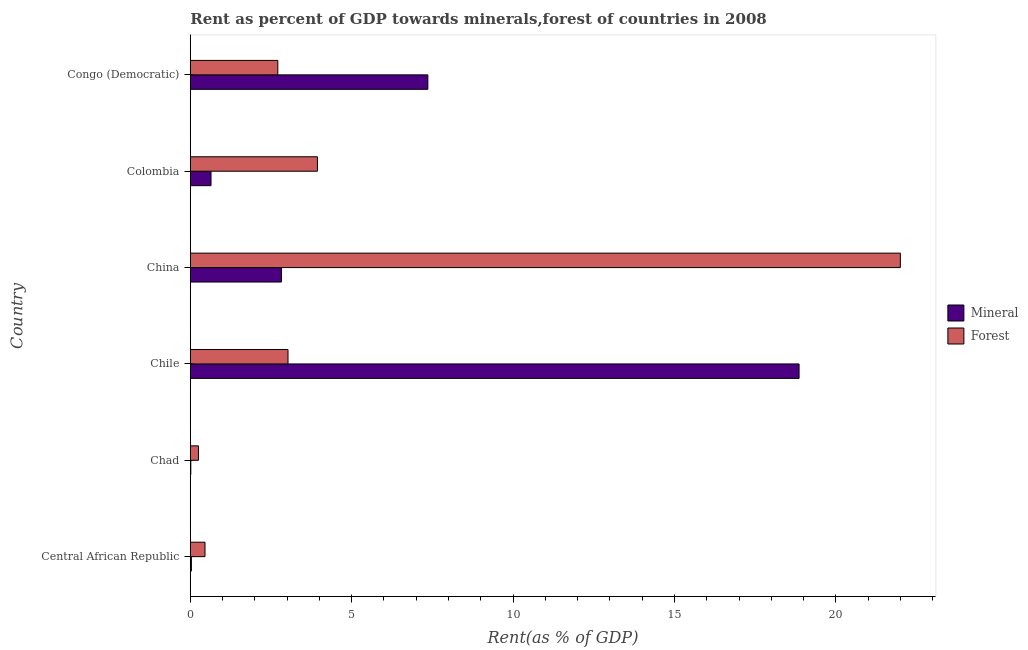How many groups of bars are there?
Provide a short and direct response. 6. How many bars are there on the 3rd tick from the top?
Your answer should be very brief. 2. What is the label of the 2nd group of bars from the top?
Your answer should be very brief. Colombia. In how many cases, is the number of bars for a given country not equal to the number of legend labels?
Offer a terse response. 0. What is the mineral rent in Congo (Democratic)?
Provide a short and direct response. 7.36. Across all countries, what is the maximum forest rent?
Your response must be concise. 22. Across all countries, what is the minimum forest rent?
Offer a terse response. 0.25. In which country was the forest rent maximum?
Make the answer very short. China. In which country was the mineral rent minimum?
Provide a succinct answer. Chad. What is the total mineral rent in the graph?
Provide a short and direct response. 29.73. What is the difference between the mineral rent in Central African Republic and that in Congo (Democratic)?
Offer a terse response. -7.33. What is the difference between the mineral rent in Colombia and the forest rent in Chile?
Provide a succinct answer. -2.39. What is the average forest rent per country?
Keep it short and to the point. 5.4. What is the difference between the forest rent and mineral rent in China?
Keep it short and to the point. 19.18. In how many countries, is the forest rent greater than 5 %?
Ensure brevity in your answer.  1. What is the ratio of the forest rent in Chad to that in Congo (Democratic)?
Make the answer very short. 0.09. Is the difference between the mineral rent in China and Congo (Democratic) greater than the difference between the forest rent in China and Congo (Democratic)?
Offer a terse response. No. What is the difference between the highest and the second highest forest rent?
Provide a succinct answer. 18.06. What is the difference between the highest and the lowest forest rent?
Offer a very short reply. 21.75. What does the 2nd bar from the top in Chile represents?
Your answer should be very brief. Mineral. What does the 2nd bar from the bottom in Chile represents?
Keep it short and to the point. Forest. How many bars are there?
Make the answer very short. 12. What is the difference between two consecutive major ticks on the X-axis?
Make the answer very short. 5. Does the graph contain grids?
Keep it short and to the point. No. How many legend labels are there?
Provide a succinct answer. 2. What is the title of the graph?
Provide a succinct answer. Rent as percent of GDP towards minerals,forest of countries in 2008. What is the label or title of the X-axis?
Your answer should be very brief. Rent(as % of GDP). What is the Rent(as % of GDP) of Mineral in Central African Republic?
Offer a very short reply. 0.03. What is the Rent(as % of GDP) of Forest in Central African Republic?
Ensure brevity in your answer.  0.46. What is the Rent(as % of GDP) in Mineral in Chad?
Offer a terse response. 0.02. What is the Rent(as % of GDP) of Forest in Chad?
Provide a short and direct response. 0.25. What is the Rent(as % of GDP) in Mineral in Chile?
Your answer should be compact. 18.86. What is the Rent(as % of GDP) in Forest in Chile?
Offer a terse response. 3.03. What is the Rent(as % of GDP) in Mineral in China?
Provide a short and direct response. 2.82. What is the Rent(as % of GDP) of Forest in China?
Your answer should be compact. 22. What is the Rent(as % of GDP) of Mineral in Colombia?
Offer a very short reply. 0.64. What is the Rent(as % of GDP) in Forest in Colombia?
Give a very brief answer. 3.94. What is the Rent(as % of GDP) of Mineral in Congo (Democratic)?
Keep it short and to the point. 7.36. What is the Rent(as % of GDP) of Forest in Congo (Democratic)?
Provide a succinct answer. 2.71. Across all countries, what is the maximum Rent(as % of GDP) of Mineral?
Offer a terse response. 18.86. Across all countries, what is the maximum Rent(as % of GDP) in Forest?
Your response must be concise. 22. Across all countries, what is the minimum Rent(as % of GDP) in Mineral?
Ensure brevity in your answer.  0.02. Across all countries, what is the minimum Rent(as % of GDP) in Forest?
Offer a terse response. 0.25. What is the total Rent(as % of GDP) in Mineral in the graph?
Ensure brevity in your answer.  29.73. What is the total Rent(as % of GDP) of Forest in the graph?
Your answer should be compact. 32.38. What is the difference between the Rent(as % of GDP) in Mineral in Central African Republic and that in Chad?
Provide a succinct answer. 0.02. What is the difference between the Rent(as % of GDP) of Forest in Central African Republic and that in Chad?
Keep it short and to the point. 0.2. What is the difference between the Rent(as % of GDP) in Mineral in Central African Republic and that in Chile?
Offer a terse response. -18.83. What is the difference between the Rent(as % of GDP) in Forest in Central African Republic and that in Chile?
Your answer should be very brief. -2.57. What is the difference between the Rent(as % of GDP) of Mineral in Central African Republic and that in China?
Offer a very short reply. -2.79. What is the difference between the Rent(as % of GDP) of Forest in Central African Republic and that in China?
Your answer should be compact. -21.54. What is the difference between the Rent(as % of GDP) in Mineral in Central African Republic and that in Colombia?
Offer a very short reply. -0.61. What is the difference between the Rent(as % of GDP) of Forest in Central African Republic and that in Colombia?
Offer a very short reply. -3.48. What is the difference between the Rent(as % of GDP) of Mineral in Central African Republic and that in Congo (Democratic)?
Make the answer very short. -7.33. What is the difference between the Rent(as % of GDP) of Forest in Central African Republic and that in Congo (Democratic)?
Ensure brevity in your answer.  -2.26. What is the difference between the Rent(as % of GDP) of Mineral in Chad and that in Chile?
Give a very brief answer. -18.84. What is the difference between the Rent(as % of GDP) of Forest in Chad and that in Chile?
Give a very brief answer. -2.77. What is the difference between the Rent(as % of GDP) in Mineral in Chad and that in China?
Offer a very short reply. -2.81. What is the difference between the Rent(as % of GDP) of Forest in Chad and that in China?
Your answer should be compact. -21.75. What is the difference between the Rent(as % of GDP) of Mineral in Chad and that in Colombia?
Ensure brevity in your answer.  -0.63. What is the difference between the Rent(as % of GDP) of Forest in Chad and that in Colombia?
Your response must be concise. -3.69. What is the difference between the Rent(as % of GDP) in Mineral in Chad and that in Congo (Democratic)?
Your response must be concise. -7.34. What is the difference between the Rent(as % of GDP) in Forest in Chad and that in Congo (Democratic)?
Make the answer very short. -2.46. What is the difference between the Rent(as % of GDP) of Mineral in Chile and that in China?
Ensure brevity in your answer.  16.04. What is the difference between the Rent(as % of GDP) in Forest in Chile and that in China?
Provide a succinct answer. -18.97. What is the difference between the Rent(as % of GDP) of Mineral in Chile and that in Colombia?
Provide a succinct answer. 18.22. What is the difference between the Rent(as % of GDP) of Forest in Chile and that in Colombia?
Keep it short and to the point. -0.91. What is the difference between the Rent(as % of GDP) in Mineral in Chile and that in Congo (Democratic)?
Ensure brevity in your answer.  11.5. What is the difference between the Rent(as % of GDP) in Forest in Chile and that in Congo (Democratic)?
Provide a short and direct response. 0.32. What is the difference between the Rent(as % of GDP) in Mineral in China and that in Colombia?
Offer a terse response. 2.18. What is the difference between the Rent(as % of GDP) in Forest in China and that in Colombia?
Your response must be concise. 18.06. What is the difference between the Rent(as % of GDP) of Mineral in China and that in Congo (Democratic)?
Keep it short and to the point. -4.54. What is the difference between the Rent(as % of GDP) in Forest in China and that in Congo (Democratic)?
Offer a very short reply. 19.29. What is the difference between the Rent(as % of GDP) of Mineral in Colombia and that in Congo (Democratic)?
Your answer should be very brief. -6.72. What is the difference between the Rent(as % of GDP) of Forest in Colombia and that in Congo (Democratic)?
Keep it short and to the point. 1.23. What is the difference between the Rent(as % of GDP) of Mineral in Central African Republic and the Rent(as % of GDP) of Forest in Chad?
Keep it short and to the point. -0.22. What is the difference between the Rent(as % of GDP) in Mineral in Central African Republic and the Rent(as % of GDP) in Forest in Chile?
Provide a succinct answer. -2.99. What is the difference between the Rent(as % of GDP) in Mineral in Central African Republic and the Rent(as % of GDP) in Forest in China?
Offer a very short reply. -21.96. What is the difference between the Rent(as % of GDP) of Mineral in Central African Republic and the Rent(as % of GDP) of Forest in Colombia?
Ensure brevity in your answer.  -3.91. What is the difference between the Rent(as % of GDP) in Mineral in Central African Republic and the Rent(as % of GDP) in Forest in Congo (Democratic)?
Keep it short and to the point. -2.68. What is the difference between the Rent(as % of GDP) in Mineral in Chad and the Rent(as % of GDP) in Forest in Chile?
Make the answer very short. -3.01. What is the difference between the Rent(as % of GDP) of Mineral in Chad and the Rent(as % of GDP) of Forest in China?
Make the answer very short. -21.98. What is the difference between the Rent(as % of GDP) in Mineral in Chad and the Rent(as % of GDP) in Forest in Colombia?
Give a very brief answer. -3.92. What is the difference between the Rent(as % of GDP) of Mineral in Chad and the Rent(as % of GDP) of Forest in Congo (Democratic)?
Make the answer very short. -2.7. What is the difference between the Rent(as % of GDP) of Mineral in Chile and the Rent(as % of GDP) of Forest in China?
Your answer should be very brief. -3.14. What is the difference between the Rent(as % of GDP) of Mineral in Chile and the Rent(as % of GDP) of Forest in Colombia?
Give a very brief answer. 14.92. What is the difference between the Rent(as % of GDP) in Mineral in Chile and the Rent(as % of GDP) in Forest in Congo (Democratic)?
Ensure brevity in your answer.  16.15. What is the difference between the Rent(as % of GDP) in Mineral in China and the Rent(as % of GDP) in Forest in Colombia?
Your response must be concise. -1.12. What is the difference between the Rent(as % of GDP) of Mineral in China and the Rent(as % of GDP) of Forest in Congo (Democratic)?
Your response must be concise. 0.11. What is the difference between the Rent(as % of GDP) of Mineral in Colombia and the Rent(as % of GDP) of Forest in Congo (Democratic)?
Your response must be concise. -2.07. What is the average Rent(as % of GDP) of Mineral per country?
Provide a succinct answer. 4.96. What is the average Rent(as % of GDP) in Forest per country?
Your response must be concise. 5.4. What is the difference between the Rent(as % of GDP) in Mineral and Rent(as % of GDP) in Forest in Central African Republic?
Provide a succinct answer. -0.42. What is the difference between the Rent(as % of GDP) of Mineral and Rent(as % of GDP) of Forest in Chad?
Give a very brief answer. -0.24. What is the difference between the Rent(as % of GDP) of Mineral and Rent(as % of GDP) of Forest in Chile?
Offer a terse response. 15.83. What is the difference between the Rent(as % of GDP) of Mineral and Rent(as % of GDP) of Forest in China?
Your answer should be compact. -19.17. What is the difference between the Rent(as % of GDP) of Mineral and Rent(as % of GDP) of Forest in Colombia?
Ensure brevity in your answer.  -3.3. What is the difference between the Rent(as % of GDP) in Mineral and Rent(as % of GDP) in Forest in Congo (Democratic)?
Provide a succinct answer. 4.65. What is the ratio of the Rent(as % of GDP) in Mineral in Central African Republic to that in Chad?
Offer a very short reply. 2.09. What is the ratio of the Rent(as % of GDP) in Forest in Central African Republic to that in Chad?
Give a very brief answer. 1.8. What is the ratio of the Rent(as % of GDP) in Mineral in Central African Republic to that in Chile?
Your response must be concise. 0. What is the ratio of the Rent(as % of GDP) of Forest in Central African Republic to that in Chile?
Ensure brevity in your answer.  0.15. What is the ratio of the Rent(as % of GDP) in Mineral in Central African Republic to that in China?
Offer a very short reply. 0.01. What is the ratio of the Rent(as % of GDP) in Forest in Central African Republic to that in China?
Offer a terse response. 0.02. What is the ratio of the Rent(as % of GDP) in Mineral in Central African Republic to that in Colombia?
Give a very brief answer. 0.05. What is the ratio of the Rent(as % of GDP) in Forest in Central African Republic to that in Colombia?
Your response must be concise. 0.12. What is the ratio of the Rent(as % of GDP) in Mineral in Central African Republic to that in Congo (Democratic)?
Offer a very short reply. 0. What is the ratio of the Rent(as % of GDP) of Forest in Central African Republic to that in Congo (Democratic)?
Offer a very short reply. 0.17. What is the ratio of the Rent(as % of GDP) of Mineral in Chad to that in Chile?
Provide a succinct answer. 0. What is the ratio of the Rent(as % of GDP) in Forest in Chad to that in Chile?
Offer a very short reply. 0.08. What is the ratio of the Rent(as % of GDP) in Mineral in Chad to that in China?
Your answer should be compact. 0.01. What is the ratio of the Rent(as % of GDP) in Forest in Chad to that in China?
Give a very brief answer. 0.01. What is the ratio of the Rent(as % of GDP) of Mineral in Chad to that in Colombia?
Your answer should be very brief. 0.02. What is the ratio of the Rent(as % of GDP) of Forest in Chad to that in Colombia?
Offer a very short reply. 0.06. What is the ratio of the Rent(as % of GDP) in Mineral in Chad to that in Congo (Democratic)?
Your response must be concise. 0. What is the ratio of the Rent(as % of GDP) of Forest in Chad to that in Congo (Democratic)?
Provide a short and direct response. 0.09. What is the ratio of the Rent(as % of GDP) in Mineral in Chile to that in China?
Keep it short and to the point. 6.68. What is the ratio of the Rent(as % of GDP) in Forest in Chile to that in China?
Make the answer very short. 0.14. What is the ratio of the Rent(as % of GDP) of Mineral in Chile to that in Colombia?
Make the answer very short. 29.38. What is the ratio of the Rent(as % of GDP) of Forest in Chile to that in Colombia?
Provide a succinct answer. 0.77. What is the ratio of the Rent(as % of GDP) of Mineral in Chile to that in Congo (Democratic)?
Keep it short and to the point. 2.56. What is the ratio of the Rent(as % of GDP) of Forest in Chile to that in Congo (Democratic)?
Keep it short and to the point. 1.12. What is the ratio of the Rent(as % of GDP) in Mineral in China to that in Colombia?
Your answer should be compact. 4.4. What is the ratio of the Rent(as % of GDP) of Forest in China to that in Colombia?
Offer a very short reply. 5.58. What is the ratio of the Rent(as % of GDP) of Mineral in China to that in Congo (Democratic)?
Offer a very short reply. 0.38. What is the ratio of the Rent(as % of GDP) in Forest in China to that in Congo (Democratic)?
Your response must be concise. 8.11. What is the ratio of the Rent(as % of GDP) in Mineral in Colombia to that in Congo (Democratic)?
Provide a succinct answer. 0.09. What is the ratio of the Rent(as % of GDP) of Forest in Colombia to that in Congo (Democratic)?
Keep it short and to the point. 1.45. What is the difference between the highest and the second highest Rent(as % of GDP) in Mineral?
Make the answer very short. 11.5. What is the difference between the highest and the second highest Rent(as % of GDP) in Forest?
Your answer should be very brief. 18.06. What is the difference between the highest and the lowest Rent(as % of GDP) of Mineral?
Make the answer very short. 18.84. What is the difference between the highest and the lowest Rent(as % of GDP) of Forest?
Your response must be concise. 21.75. 